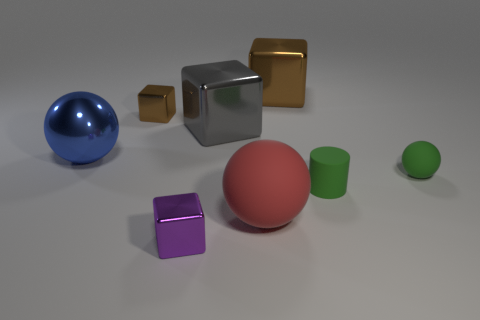Are there any big gray shiny blocks in front of the purple block?
Provide a short and direct response. No. How many brown things are either tiny shiny cylinders or small cylinders?
Ensure brevity in your answer.  0. Is the material of the tiny purple object the same as the large blue object that is in front of the tiny brown cube?
Make the answer very short. Yes. There is a green matte thing that is the same shape as the big blue thing; what is its size?
Make the answer very short. Small. What is the tiny green cylinder made of?
Provide a short and direct response. Rubber. What is the material of the ball that is to the left of the small cube in front of the large gray shiny object that is behind the cylinder?
Give a very brief answer. Metal. Is the size of the brown metal object right of the big gray metal block the same as the sphere that is to the left of the tiny brown cube?
Give a very brief answer. Yes. What number of other things are there of the same material as the large gray object
Offer a very short reply. 4. How many shiny objects are either tiny purple blocks or purple spheres?
Your answer should be compact. 1. Are there fewer big blue spheres than small green matte things?
Offer a very short reply. Yes. 